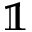Convert formula to latex. <formula><loc_0><loc_0><loc_500><loc_500>\mathbb { 1 }</formula> 